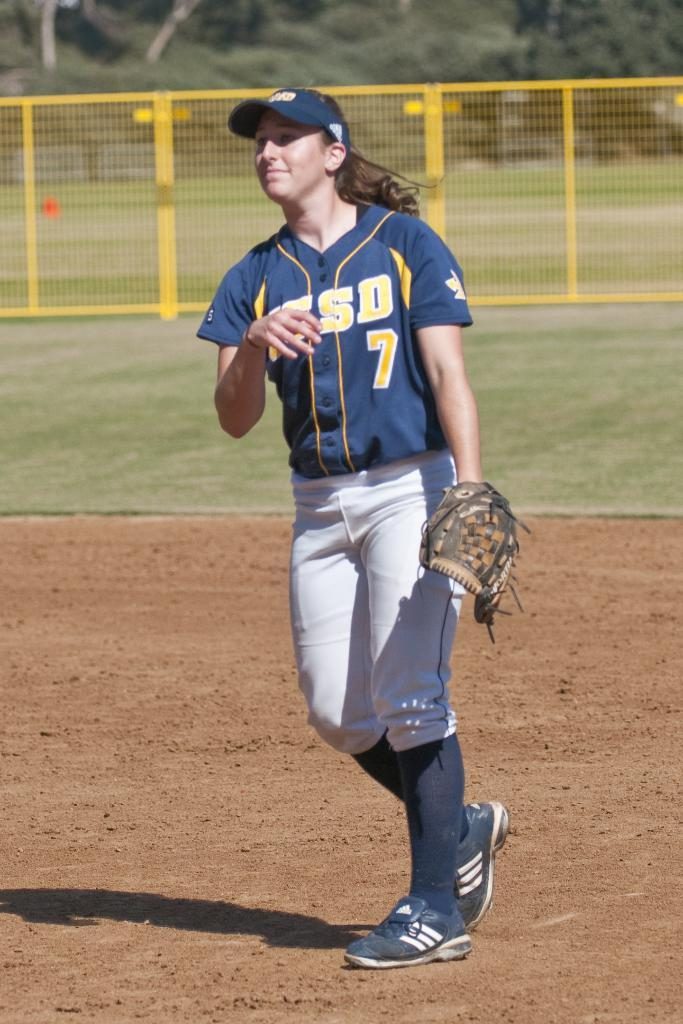<image>
Create a compact narrative representing the image presented. A girl wearing a blue and yellow softball jersey with the number 7 on it stands in the dirt on a softball field. 